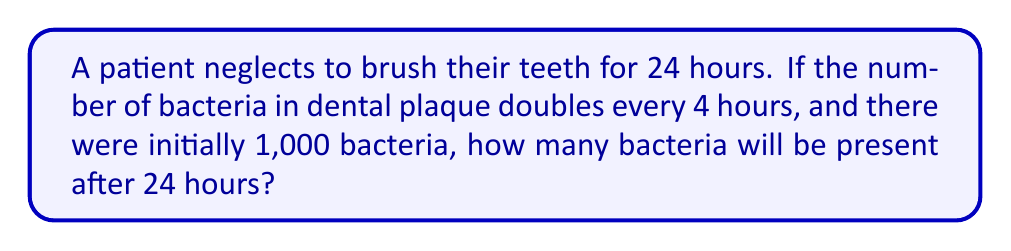Could you help me with this problem? Let's approach this step-by-step:

1) First, we need to determine how many times the bacteria population doubles in 24 hours:
   $\frac{24 \text{ hours}}{4 \text{ hours per doubling}} = 6 \text{ doublings}$

2) We can represent this mathematically as:
   $1000 \cdot 2^6$

3) Let's calculate $2^6$:
   $2^6 = 2 \cdot 2 \cdot 2 \cdot 2 \cdot 2 \cdot 2 = 64$

4) Now, we multiply the initial number of bacteria by this result:
   $1000 \cdot 64 = 64,000$

Therefore, after 24 hours, there will be 64,000 bacteria in the dental plaque.

This can also be represented using exponential notation:
$$1000 \cdot 2^6 = 1000 \cdot 64 = 64,000$$

This exponential growth demonstrates why regular brushing is crucial for maintaining oral health and preventing the rapid multiplication of harmful bacteria in dental plaque.
Answer: 64,000 bacteria 